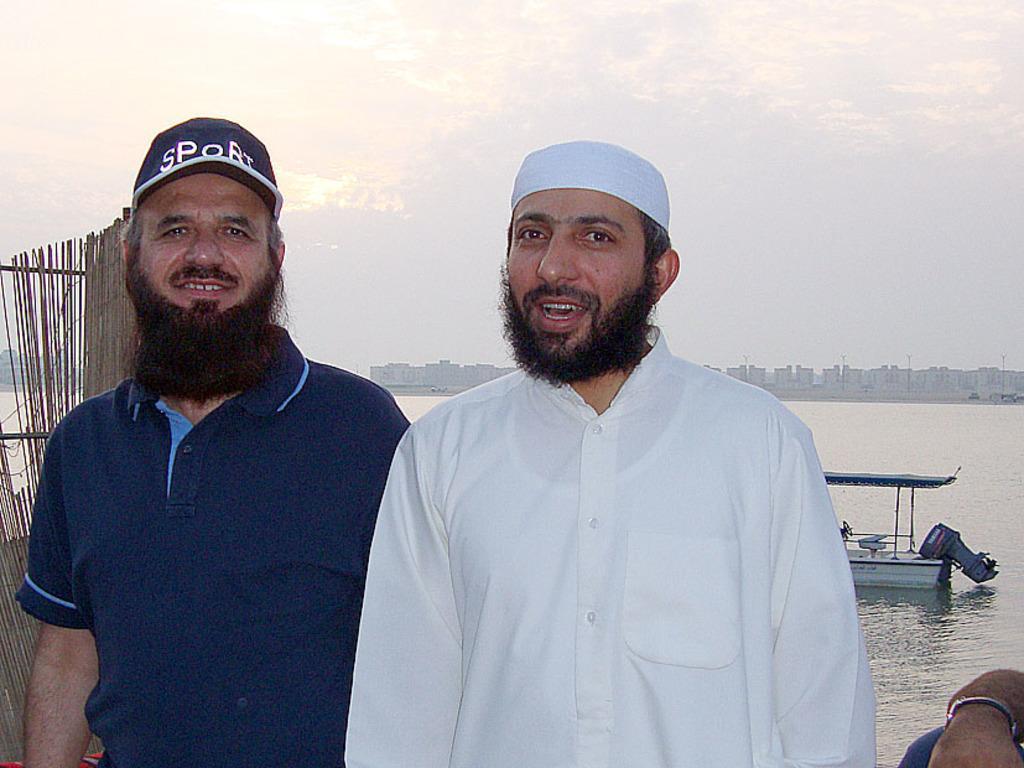Could you give a brief overview of what you see in this image? In this picture we can observe two men standing. They are wearing blue and white color dresses. Both of them are wearing caps on their heads. Behind them we can observe a river and a boat floating on the river. In the background there are buildings and a sky with some clouds. 